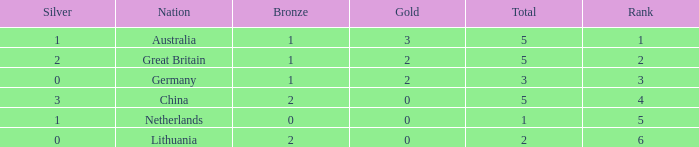Give me the full table as a dictionary. {'header': ['Silver', 'Nation', 'Bronze', 'Gold', 'Total', 'Rank'], 'rows': [['1', 'Australia', '1', '3', '5', '1'], ['2', 'Great Britain', '1', '2', '5', '2'], ['0', 'Germany', '1', '2', '3', '3'], ['3', 'China', '2', '0', '5', '4'], ['1', 'Netherlands', '0', '0', '1', '5'], ['0', 'Lithuania', '2', '0', '2', '6']]} How many total show when silver is 0, bronze is 1, and the rank is less than 3? 0.0. 